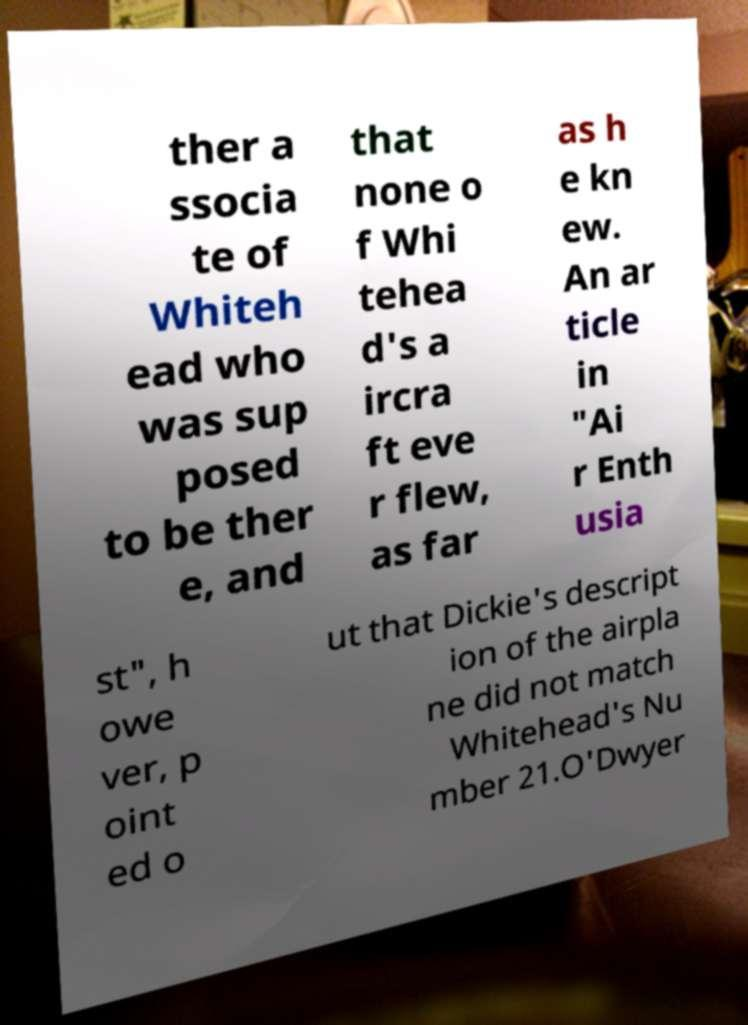Can you accurately transcribe the text from the provided image for me? ther a ssocia te of Whiteh ead who was sup posed to be ther e, and that none o f Whi tehea d's a ircra ft eve r flew, as far as h e kn ew. An ar ticle in "Ai r Enth usia st", h owe ver, p oint ed o ut that Dickie's descript ion of the airpla ne did not match Whitehead's Nu mber 21.O'Dwyer 